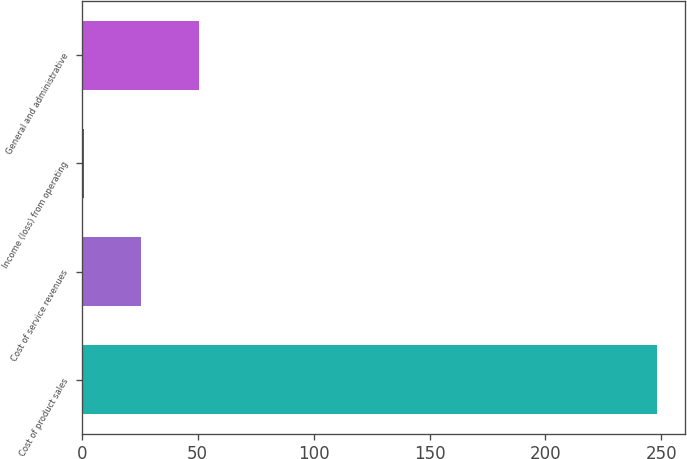Convert chart. <chart><loc_0><loc_0><loc_500><loc_500><bar_chart><fcel>Cost of product sales<fcel>Cost of service revenues<fcel>Income (loss) from operating<fcel>General and administrative<nl><fcel>248<fcel>25.7<fcel>1<fcel>50.4<nl></chart> 